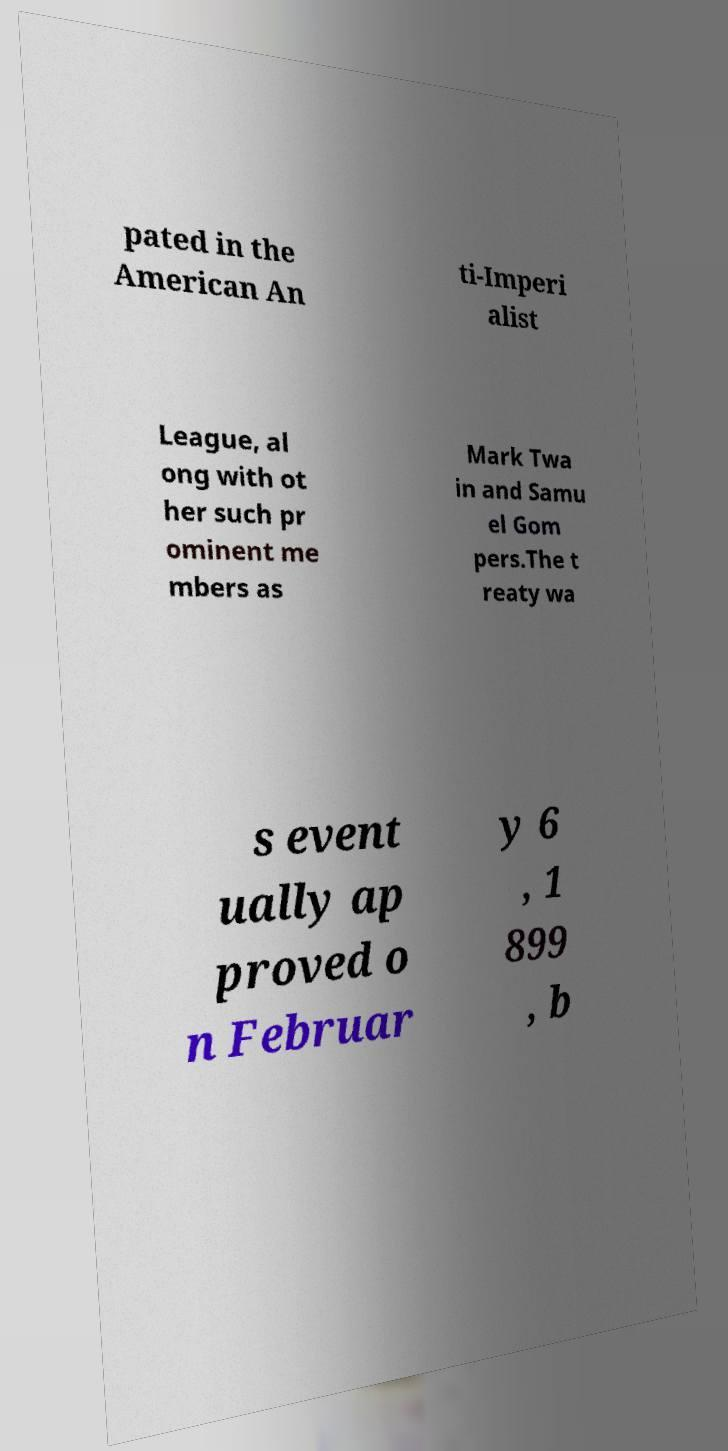Please identify and transcribe the text found in this image. pated in the American An ti-Imperi alist League, al ong with ot her such pr ominent me mbers as Mark Twa in and Samu el Gom pers.The t reaty wa s event ually ap proved o n Februar y 6 , 1 899 , b 